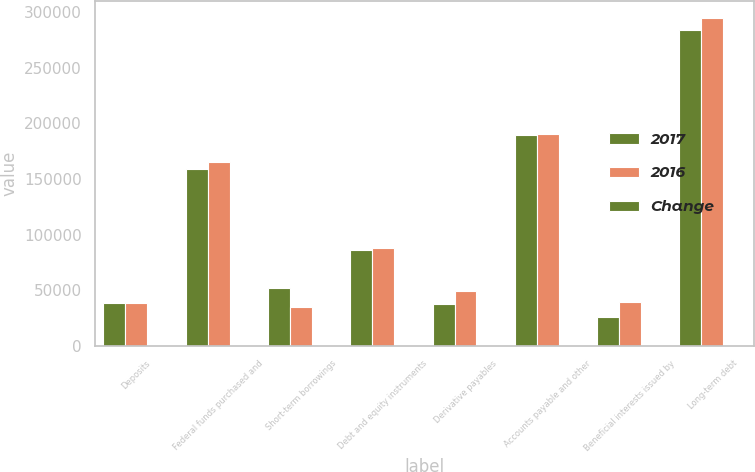Convert chart. <chart><loc_0><loc_0><loc_500><loc_500><stacked_bar_chart><ecel><fcel>Deposits<fcel>Federal funds purchased and<fcel>Short-term borrowings<fcel>Debt and equity instruments<fcel>Derivative payables<fcel>Accounts payable and other<fcel>Beneficial interests issued by<fcel>Long-term debt<nl><fcel>2017<fcel>38412<fcel>158916<fcel>51802<fcel>85886<fcel>37777<fcel>189383<fcel>26081<fcel>284080<nl><fcel>2016<fcel>38412<fcel>165666<fcel>34443<fcel>87428<fcel>49231<fcel>190543<fcel>39047<fcel>295245<nl><fcel>Change<fcel>5<fcel>4<fcel>50<fcel>2<fcel>23<fcel>1<fcel>33<fcel>4<nl></chart> 